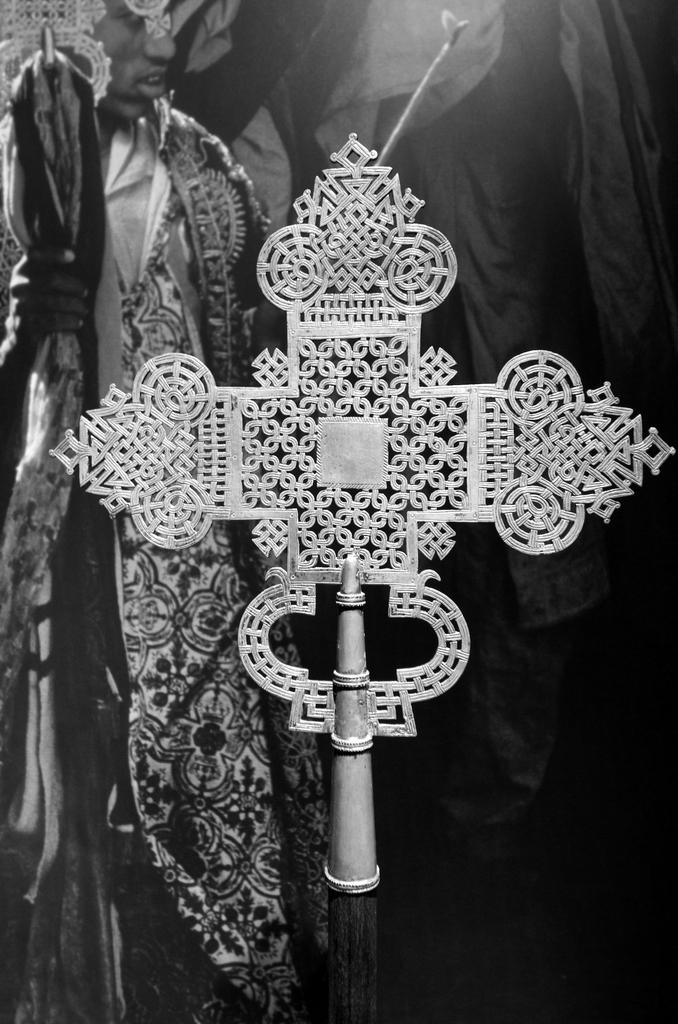What is the color scheme of the image? The image is black and white. What can be seen in the image? There are objects in the image. Can you describe the person in the background of the image? There is a person in the background of the image, and they are holding an object in their hand. What else can be seen in the background of the image? There are clothes visible in the background of the image. What type of bead is the person using to make a credit transaction in the image? There is no bead or credit transaction present in the image. Is there a market visible in the image? There is no market visible in the image. 